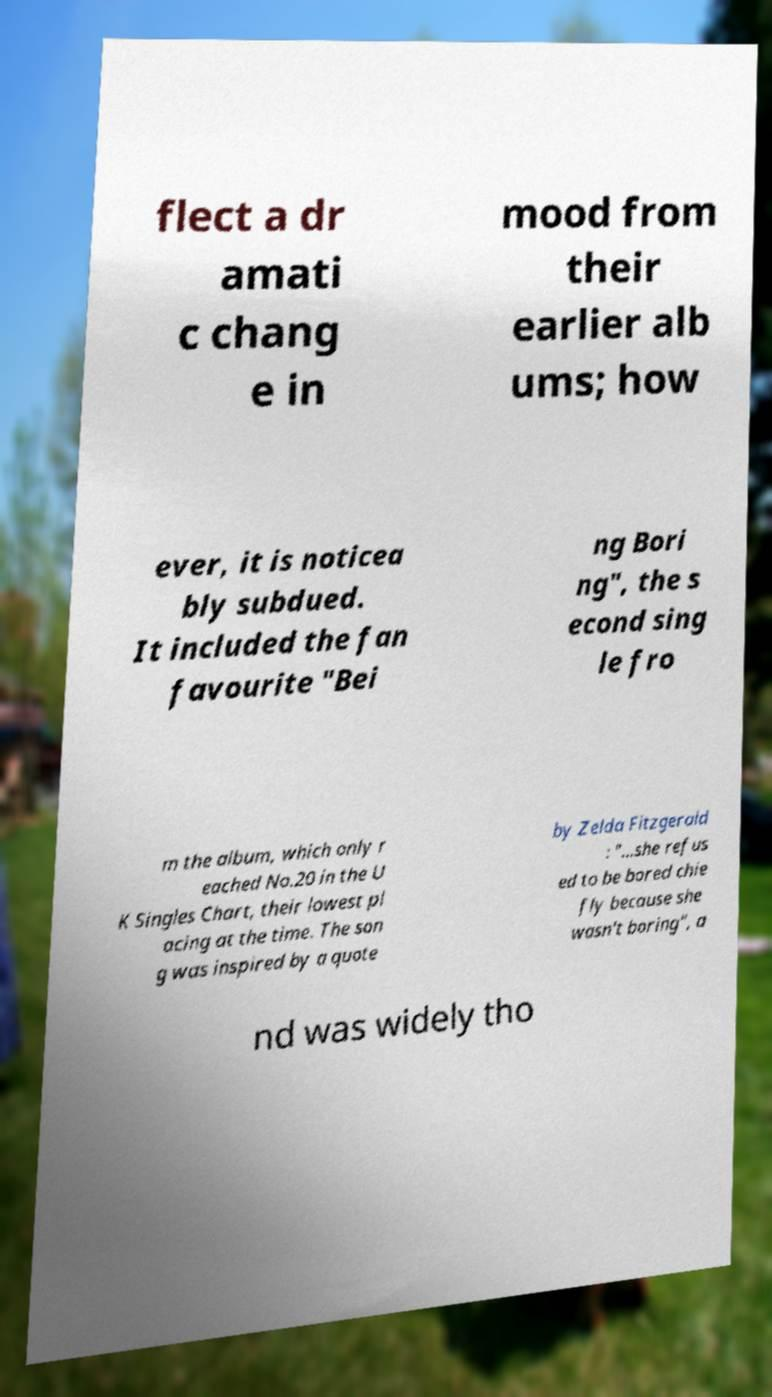Can you read and provide the text displayed in the image?This photo seems to have some interesting text. Can you extract and type it out for me? flect a dr amati c chang e in mood from their earlier alb ums; how ever, it is noticea bly subdued. It included the fan favourite "Bei ng Bori ng", the s econd sing le fro m the album, which only r eached No.20 in the U K Singles Chart, their lowest pl acing at the time. The son g was inspired by a quote by Zelda Fitzgerald : "...she refus ed to be bored chie fly because she wasn't boring", a nd was widely tho 